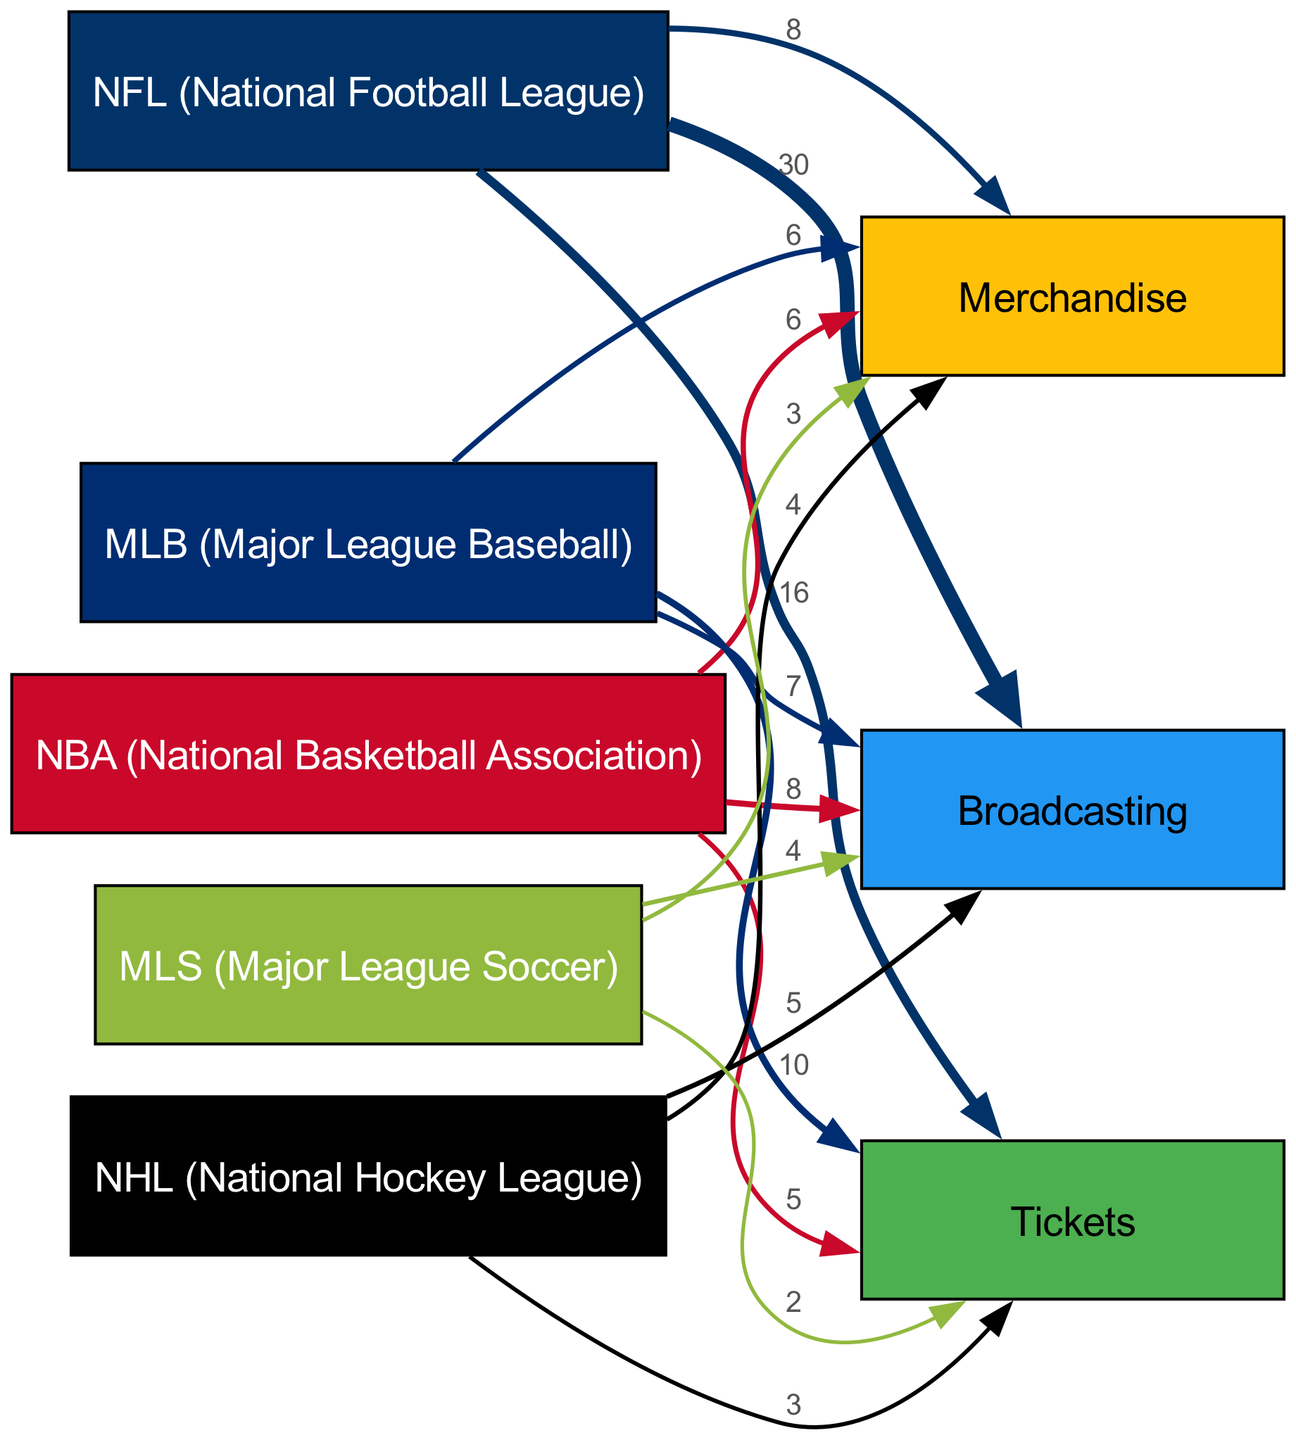What is the total revenue from broadcasting for the NFL? The link from NFL to Broadcasting has a value of 30, which represents the total revenue from broadcasting for the NFL.
Answer: 30 Which league has the highest revenue from tickets? By comparing the links from each league to the Tickets node, the NFL has the highest value of 16 for tickets.
Answer: NFL What is the value of merchandise revenue for the NBA? The link from NBA to Merchandise shows a value of 6, indicating the merchandise revenue for the NBA.
Answer: 6 How does the broadcasting revenue of MLB compare to that of NHL? MLB has a broadcasting revenue of 7, while NHL has 5. Comparing these values shows that MLB's broadcasting revenue is greater than NHL's by 2.
Answer: MLB is greater Which sport has the least revenue from tickets? The link from MLS to Tickets shows a value of 2, which is the lowest among all leagues for ticket revenue, indicating that MLS generates the least revenue from this source.
Answer: MLS What is the total sum of all ticket revenues across all leagues? To calculate this, we sum the values of the Tickets link for each league: NFL (16) + NBA (5) + MLB (10) + NHL (3) + MLS (2) equals 36.
Answer: 36 Which source generates the most overall revenue for the NFL? By examining the values of all the links for NFL, Broadcasting has the highest value of 30, indicating it is the top source of revenue for the NFL.
Answer: Broadcasting How much does the NHL earn from merchandise compared to the MLS? NHL earns 4 from Merchandise while MLS earns 3. Therefore, NHL earns 1 more than MLS from merchandise.
Answer: NHL earns 1 more What percentage of the total revenue from the NBA is derived from tickets? The total revenue for NBA is the sum of its three sources: Tickets (5) + Merchandise (6) + Broadcasting (8), which is 19. The percentage from tickets is (5/19) * 100 = 26.32%.
Answer: 26.32% 